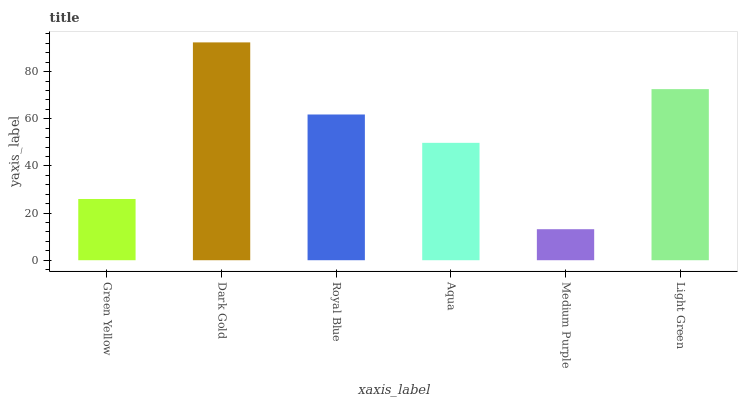Is Royal Blue the minimum?
Answer yes or no. No. Is Royal Blue the maximum?
Answer yes or no. No. Is Dark Gold greater than Royal Blue?
Answer yes or no. Yes. Is Royal Blue less than Dark Gold?
Answer yes or no. Yes. Is Royal Blue greater than Dark Gold?
Answer yes or no. No. Is Dark Gold less than Royal Blue?
Answer yes or no. No. Is Royal Blue the high median?
Answer yes or no. Yes. Is Aqua the low median?
Answer yes or no. Yes. Is Aqua the high median?
Answer yes or no. No. Is Royal Blue the low median?
Answer yes or no. No. 